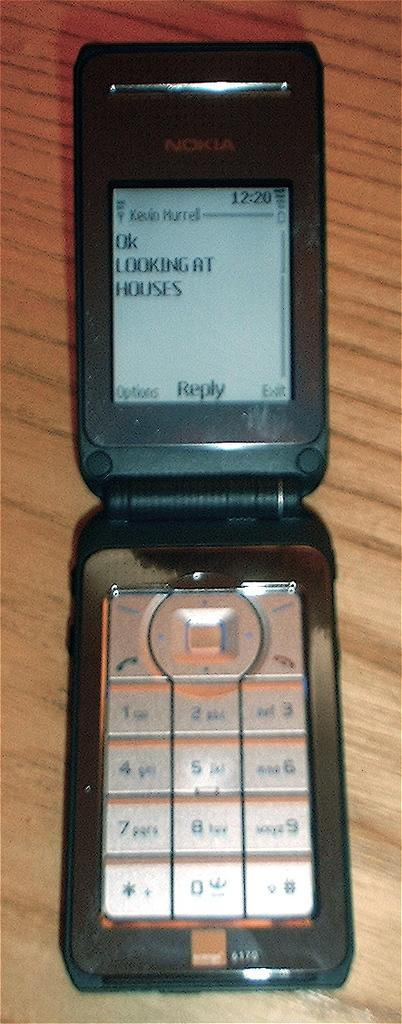<image>
Render a clear and concise summary of the photo. A black Nokia flip phone opened with a message that says "OK Looking at Houses" 